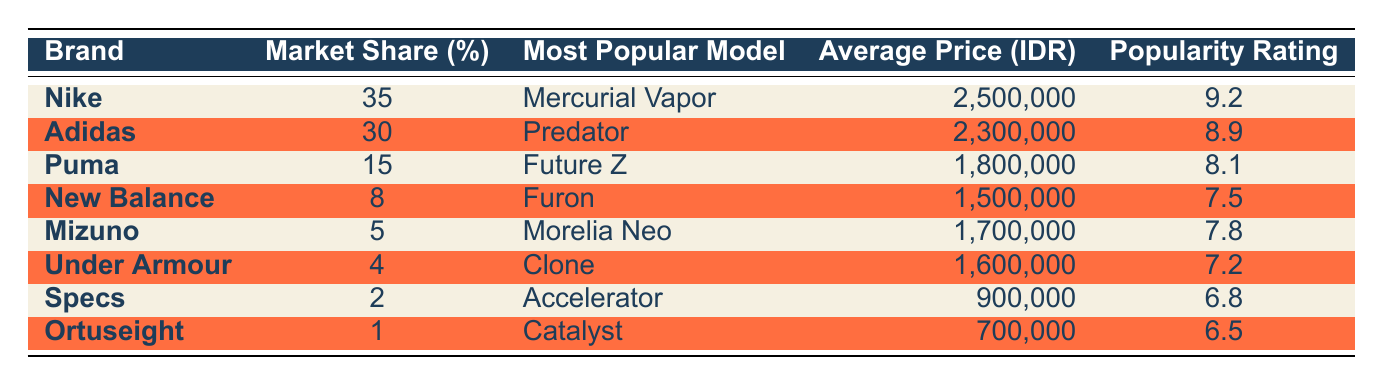What is the market share percentage of Nike? The table shows that Nike has a market share of 35%.
Answer: 35% Which brand has the most popular model called "Predator"? The table indicates that Adidas has the most popular model called "Predator".
Answer: Adidas What is the average price of Puma football boots? According to the table, the average price of Puma football boots (Future Z) is 1,800,000 IDR.
Answer: 1,800,000 IDR What brand has the lowest popularity rating? The table reveals that Ortuseight has the lowest popularity rating at 6.5.
Answer: Ortuseight What is the difference in market share between Nike and Adidas? Nike has a market share of 35% while Adidas has 30%, so the difference is 35 - 30 = 5%.
Answer: 5% What is the average price of the top three boot brands? The three brands are Nike (2,500,000 IDR), Adidas (2,300,000 IDR), and Puma (1,800,000 IDR). The average price is (2,500,000 + 2,300,000 + 1,800,000) / 3 = 2,200,000 IDR.
Answer: 2,200,000 IDR Which brand has a market share less than 10%? The table lists New Balance (8%), Mizuno (5%), Under Armour (4%), Specs (2%), and Ortuseight (1%) as brands with market shares less than 10%.
Answer: New Balance, Mizuno, Under Armour, Specs, Ortuseight What is the total market share percentage of the brands with a popularity rating above 8? The brands with ratings above 8 are Nike (35%), Adidas (30%), and Puma (15%). The total market share is 35 + 30 + 15 = 80%.
Answer: 80% Is the most popular model of Under Armour also the cheapest? Under Armour's model "Clone" is priced at 1,600,000 IDR, while the cheapest model is "Accelerator" from Specs, priced at 900,000 IDR. Since 900,000 IDR is less than 1,600,000 IDR, the statement is true.
Answer: No Which brand has the most popular model and highest popularity rating? Nike has the most popular model "Mercurial Vapor" and also has the highest popularity rating of 9.2.
Answer: Nike 